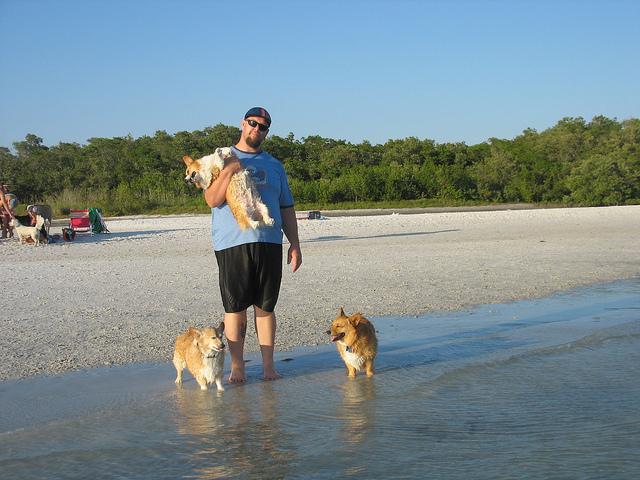Are the dogs wet?
Concise answer only. Yes. What dogs is this?
Answer briefly. Corgi. Is the man holding a child?
Short answer required. No. 